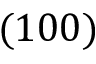Convert formula to latex. <formula><loc_0><loc_0><loc_500><loc_500>( 1 0 0 )</formula> 